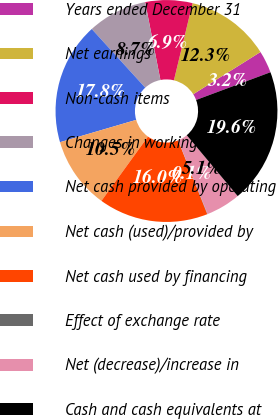Convert chart. <chart><loc_0><loc_0><loc_500><loc_500><pie_chart><fcel>Years ended December 31<fcel>Net earnings<fcel>Non-cash items<fcel>Changes in working capital<fcel>Net cash provided by operating<fcel>Net cash (used)/provided by<fcel>Net cash used by financing<fcel>Effect of exchange rate<fcel>Net (decrease)/increase in<fcel>Cash and cash equivalents at<nl><fcel>3.24%<fcel>12.3%<fcel>6.86%<fcel>8.68%<fcel>17.77%<fcel>10.49%<fcel>15.96%<fcel>0.05%<fcel>5.05%<fcel>19.59%<nl></chart> 